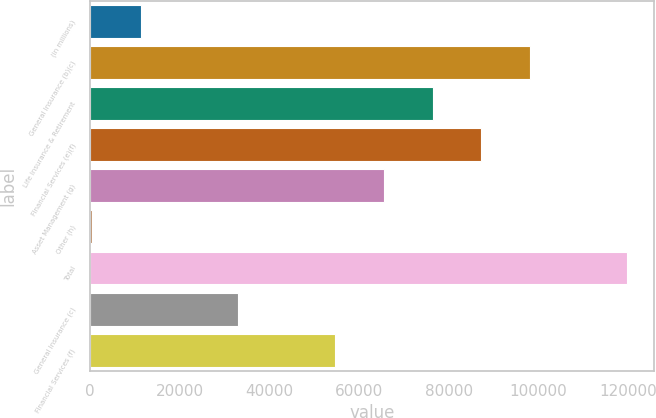Convert chart to OTSL. <chart><loc_0><loc_0><loc_500><loc_500><bar_chart><fcel>(in millions)<fcel>General Insurance (b)(c)<fcel>Life Insurance & Retirement<fcel>Financial Services (e)(f)<fcel>Asset Management (g)<fcel>Other (h)<fcel>Total<fcel>General Insurance (c)<fcel>Financial Services (f)<nl><fcel>11345<fcel>98065<fcel>76385<fcel>87225<fcel>65545<fcel>505<fcel>119745<fcel>33025<fcel>54705<nl></chart> 